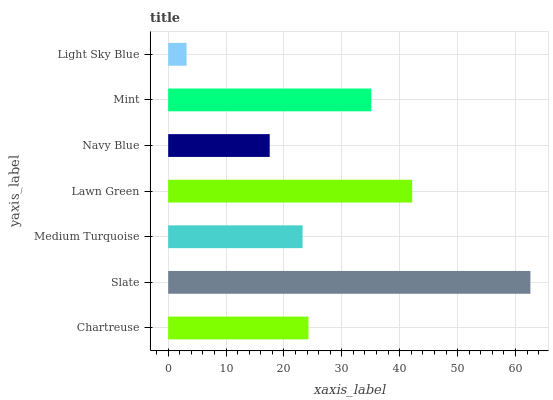Is Light Sky Blue the minimum?
Answer yes or no. Yes. Is Slate the maximum?
Answer yes or no. Yes. Is Medium Turquoise the minimum?
Answer yes or no. No. Is Medium Turquoise the maximum?
Answer yes or no. No. Is Slate greater than Medium Turquoise?
Answer yes or no. Yes. Is Medium Turquoise less than Slate?
Answer yes or no. Yes. Is Medium Turquoise greater than Slate?
Answer yes or no. No. Is Slate less than Medium Turquoise?
Answer yes or no. No. Is Chartreuse the high median?
Answer yes or no. Yes. Is Chartreuse the low median?
Answer yes or no. Yes. Is Mint the high median?
Answer yes or no. No. Is Navy Blue the low median?
Answer yes or no. No. 